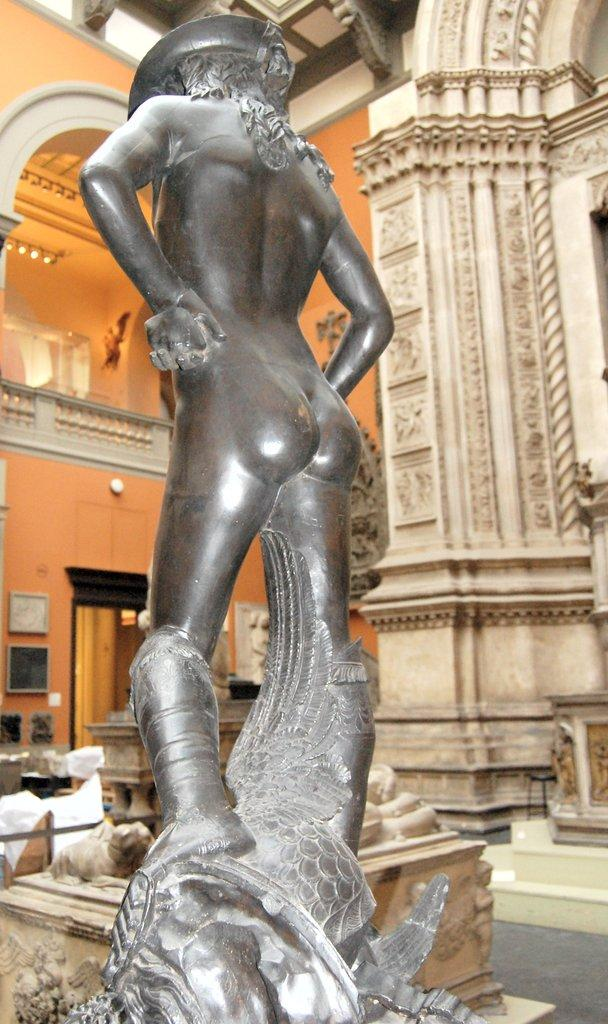What is the main subject of the image? The main subject of the image is a statue of a human. Where is the statue located? The statue is inside a fort. Can you tell me how many strangers are visible in the image? There is no stranger present in the image; it only features a statue of a human inside a fort. What type of throat condition can be seen in the image? There is no throat or any medical condition visible in the image; it only features a statue of a human inside a fort. 